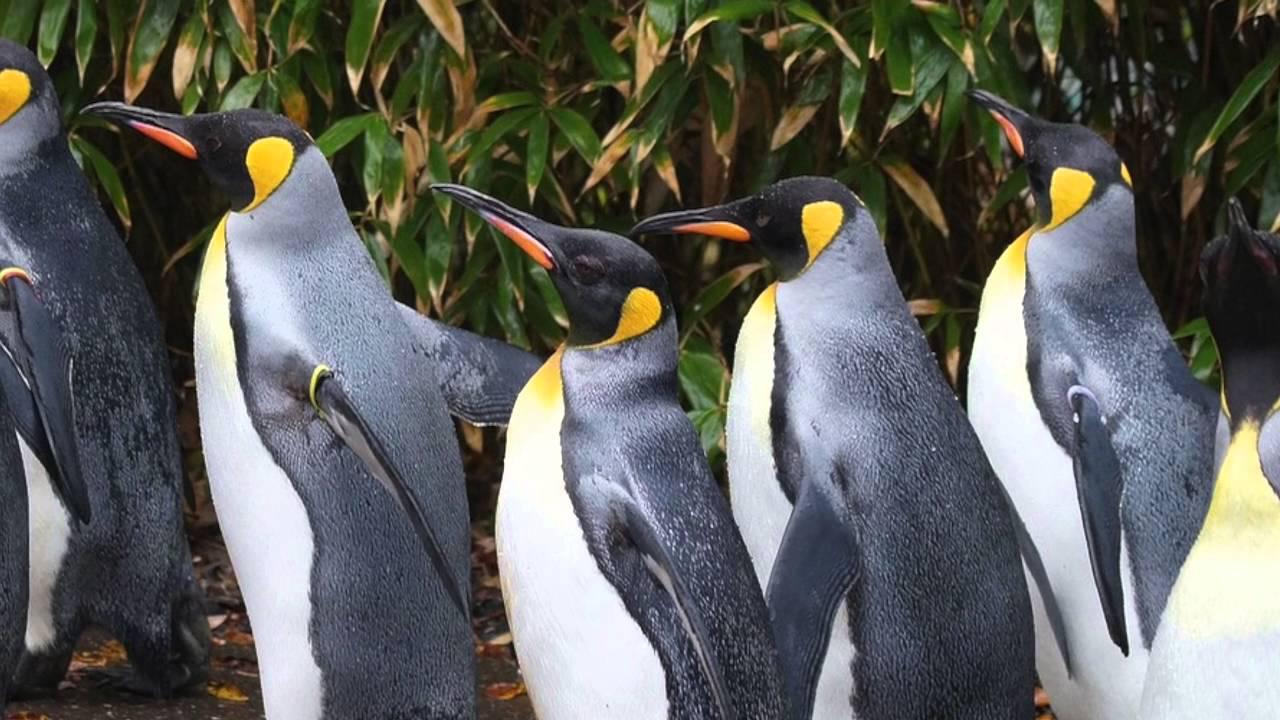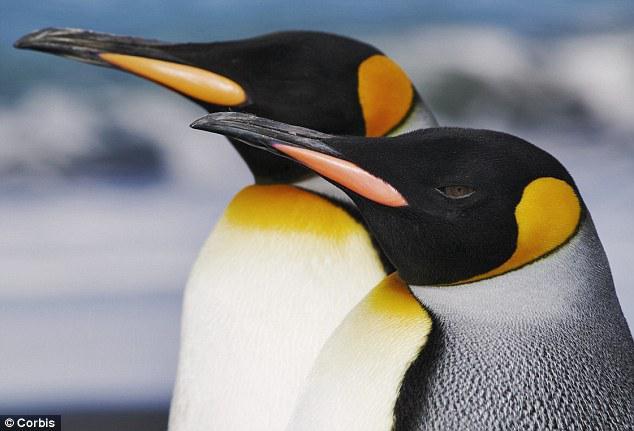The first image is the image on the left, the second image is the image on the right. For the images displayed, is the sentence "An image includes multiple penguins with fuzzy brown feathers, along with at least one black and white penguin." factually correct? Answer yes or no. No. The first image is the image on the left, the second image is the image on the right. For the images displayed, is the sentence "There is at least one brown furry penguin." factually correct? Answer yes or no. No. 